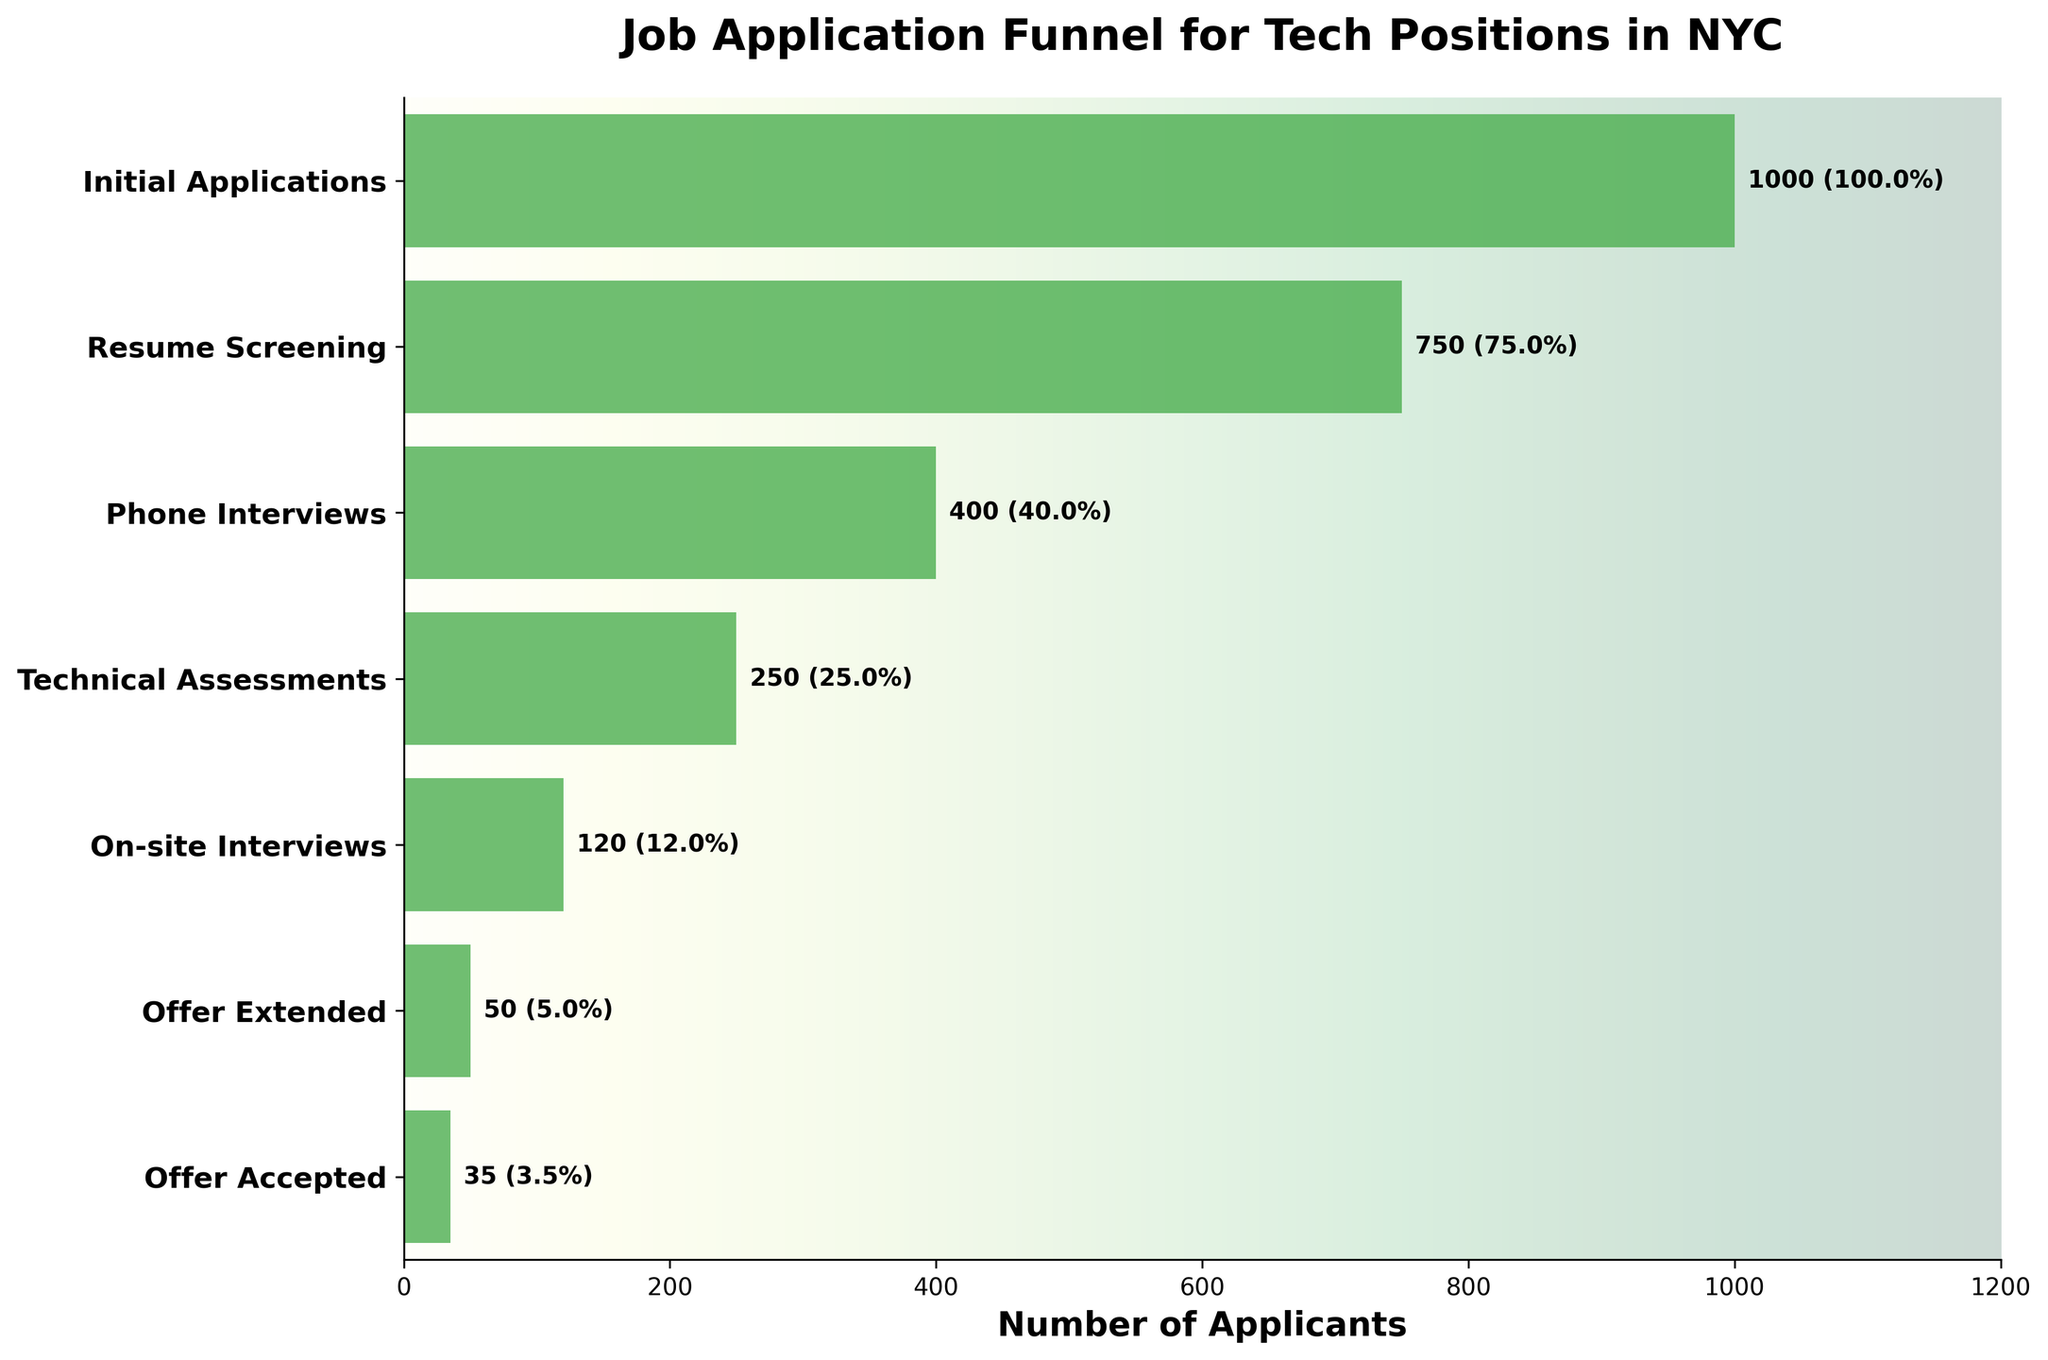What is the title of the chart? The title is displayed at the top of the chart. Simply reading it will give us the required information.
Answer: Job Application Funnel for Tech Positions in NYC How many applicants reached the On-site Interviews stage? Locate the "On-site Interviews" stage on the y-axis and read the corresponding bar value.
Answer: 120 What is the percentage reduction from Resume Screening to Phone Interviews? Find the number of applicants for both stages: Resume Screening (750) and Phone Interviews (400). Calculate the reduction: (750 - 400) / 750 * 100%.
Answer: 46.7% Which stage sees the highest drop in the number of applicants? Compare the differences between consecutive stages: Initial Applications (1000) to Resume Screening (750), Resume Screening (750) to Phone Interviews (400), etc. The largest drop is between Resume Screening and Phone Interviews (750 - 400).
Answer: Resume Screening to Phone Interviews How many stages are included in the funnel chart? Count the number of unique stages listed on the y-axis.
Answer: 7 At which stage does the percentage drop below 50% of the initial number of applicants? Refer to the percentages for each stage and identify the first stage with a percentage below 50%. The "Phone Interviews" stage shows 40% which is below 50%.
Answer: Phone Interviews How many more applicants were extended offers compared to those who accepted the offer? Read the number of applicants for both stages: Offer Extended (50) and Offer Accepted (35). Subtract the number of Offer Accepted from Offer Extended: 50 - 35.
Answer: 15 Which stage had the smallest percentage decrease from the previous stage? Calculate the percentage decrease between all consecutive stages and compare. For example, (1000-750)/1000 for the first two stages. The smallest decrease in percentage terms is between Technical Assessments (250) and On-site Interviews (120).
Answer: Technical Assessments to On-site Interviews 